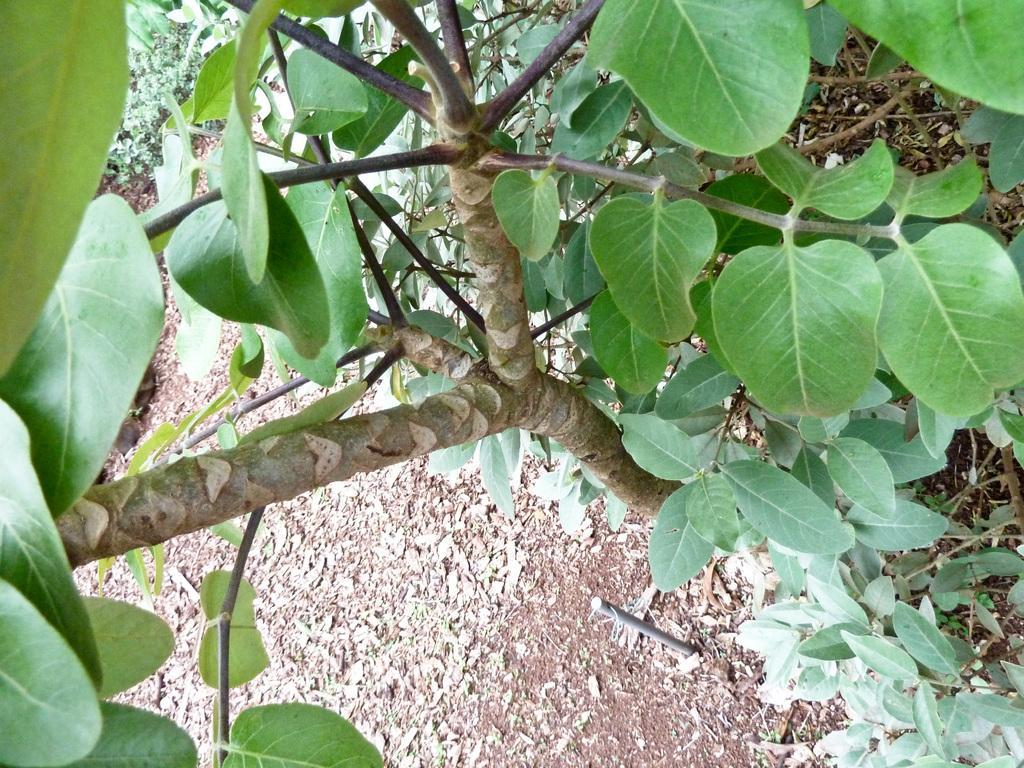Please provide a concise description of this image. In this image I can see trees and plants in green color and I can also see few dried leaves on the ground. 